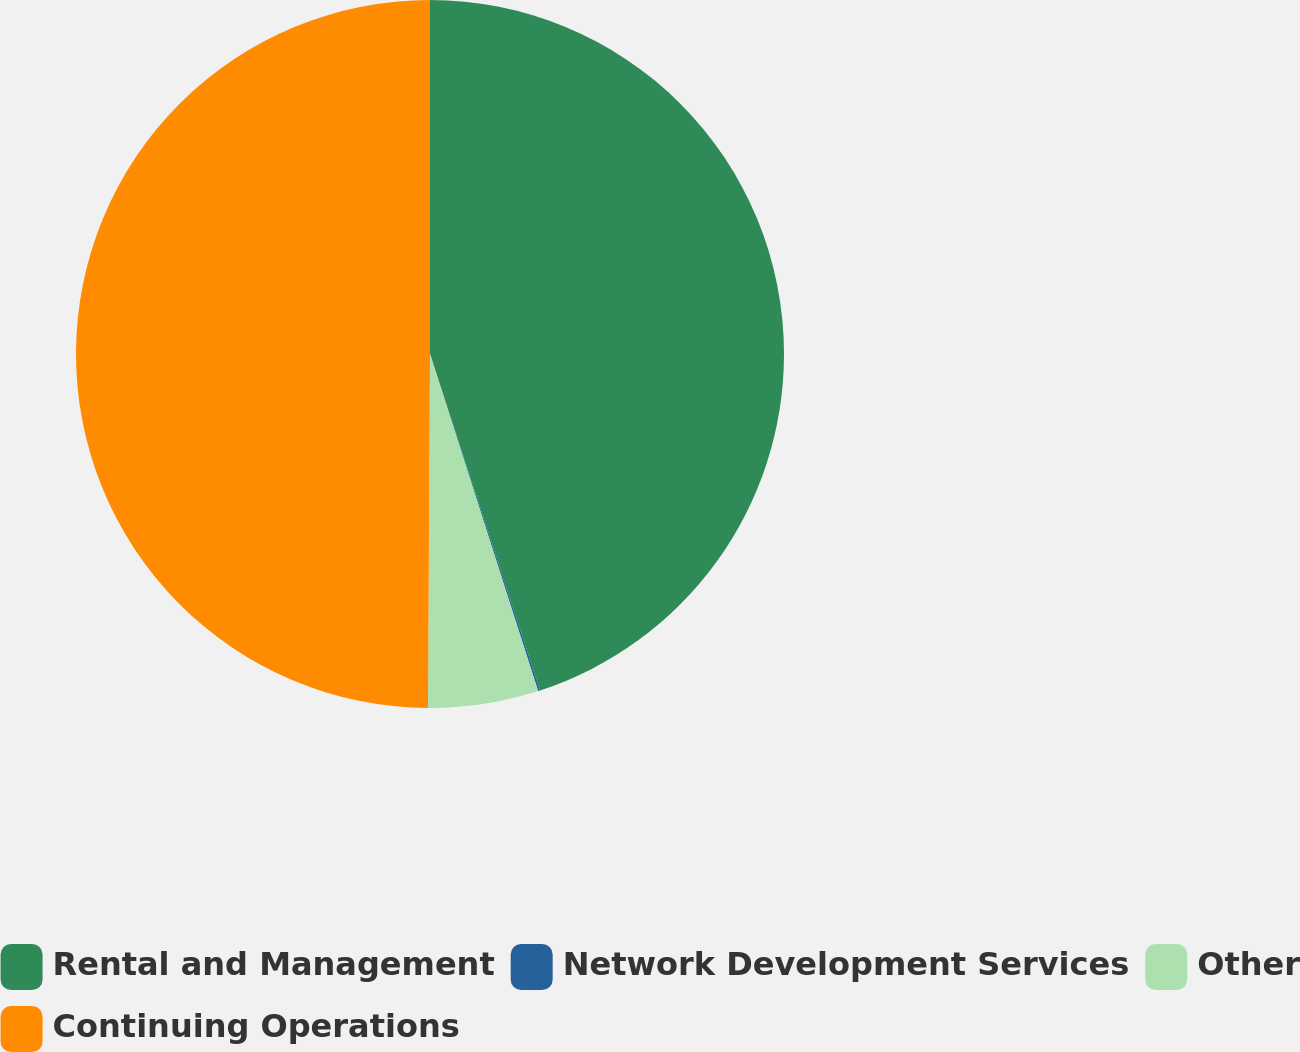<chart> <loc_0><loc_0><loc_500><loc_500><pie_chart><fcel>Rental and Management<fcel>Network Development Services<fcel>Other<fcel>Continuing Operations<nl><fcel>44.97%<fcel>0.09%<fcel>5.03%<fcel>49.91%<nl></chart> 